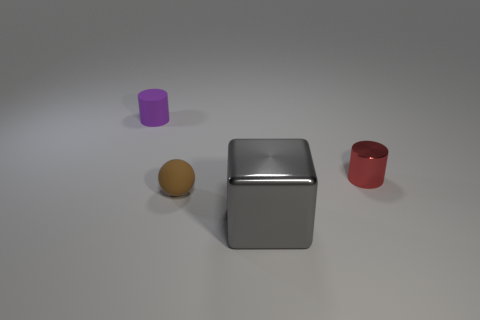Subtract all red cylinders. How many cylinders are left? 1 Subtract all balls. How many objects are left? 3 Add 4 large metallic objects. How many objects exist? 8 Subtract all blue cylinders. Subtract all brown spheres. How many cylinders are left? 2 Add 3 small brown objects. How many small brown objects are left? 4 Add 3 tiny rubber balls. How many tiny rubber balls exist? 4 Subtract 1 gray cubes. How many objects are left? 3 Subtract all red things. Subtract all tiny spheres. How many objects are left? 2 